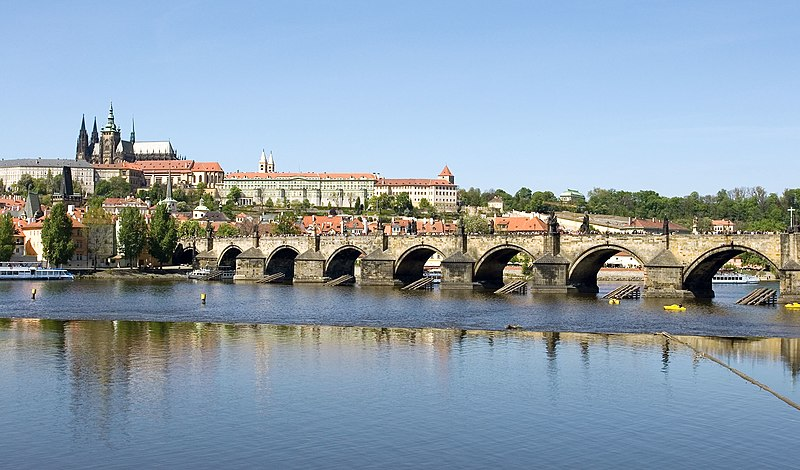Can you tell me more about the historical significance of the Charles Bridge? Certainly! The Charles Bridge has a rich history dating back to the 14th century. Commissioned by King Charles IV, construction began in 1357 and it was completed in the early 15th century. The bridge not only served a crucial transportation route but also became a significant site for various historic events. Over time, it has endured numerous floods and battles, yet it remains a symbol of Prague's resilience and cultural heritage. What are some interesting myths or legends associated with the Charles Bridge? One intriguing legend is that egg yolks were mixed into the mortar to strengthen the construction of the bridge. Another fascinating myth is about the old statue of St. John of Nepomuk, which is said to grant wishes to those who touch the plaque below it. St. John was martyred by being thrown into the Vltava River, and his statue now watches over the bridge, adding to its mystical allure. Can you envision a magical event happening on the Charles Bridge? Imagine a moonlit night where the statues on the Charles Bridge come to life. As midnight approaches, they step down from their pedestals and gather in the middle of the bridge. The statues, now animated, begin to tell stories of old Prague, sharing secrets and recounting battles fought. The river reflects their ghostly figures, creating an ethereal glow. Passersby unaware of this enchanted hour experience a once-in-a-lifetime glimpse into Prague's living history. 